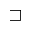Convert formula to latex. <formula><loc_0><loc_0><loc_500><loc_500>\sqsupset</formula> 